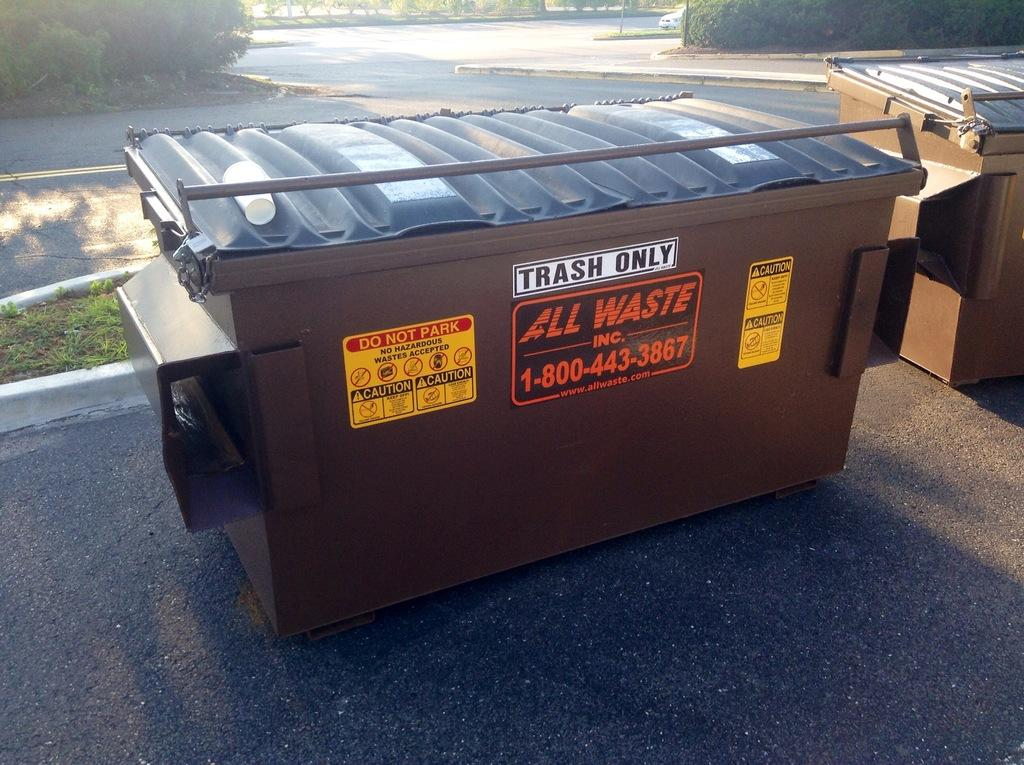<image>
Share a concise interpretation of the image provided. A dumpster says "trash only" and looks very clean and new. 